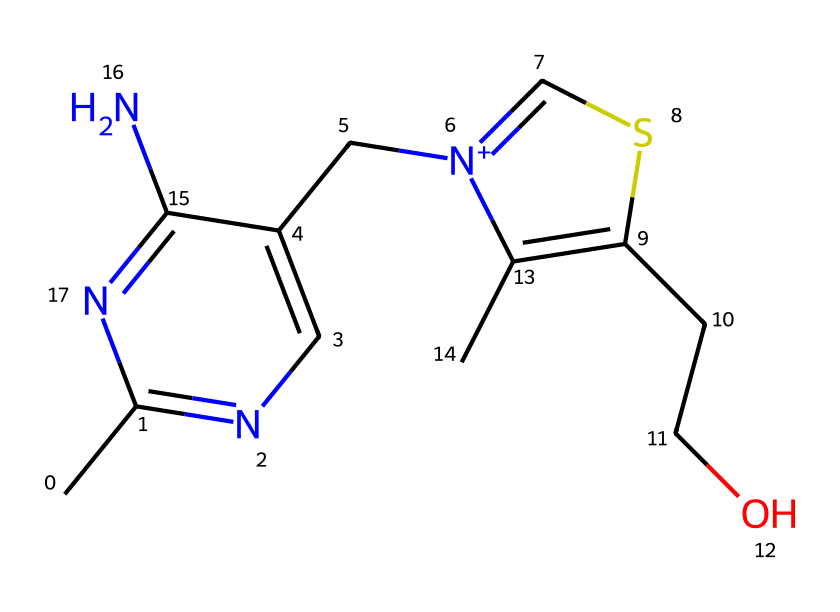What is the main functional group present in thiamine (Vitamin B1)? The main functional group in thiamine is the thiazole ring, which contains sulfur and nitrogen. This can be identified by looking for the five-membered ring that includes sulfur as part of its structure.
Answer: thiazole ring How many nitrogen atoms are in the thiamine structure? To determine the number of nitrogen atoms, I can simply count the 'N' symbols in the SMILES representation. There are two 'N' symbols present, indicating two nitrogen atoms in the structure.
Answer: two What type of molecule is thiamine categorized as? Thiamine is categorized as a vitamin, specifically B1. It is a water-soluble vitamin that plays a crucial role in carbohydrate metabolism. The chemical structure indicates that it is a small organic molecule.
Answer: vitamin How many carbon atoms are in thiamine? By analyzing the SMILES notation, I can count the occurrences of 'C' that represent carbon atoms. There are seven 'C' symbols, indicating that thiamine contains seven carbon atoms.
Answer: seven Is the thiamine structure aromatic? To evaluate if the structure is aromatic, I can check for cyclic structures that comply with Huckel's rule (4n + 2 π electrons) and also display delocalized electrons. The presence of the two rings suggests potential aromatic characteristics. Based on its structure, thiamine is not fully aromatic but has components that have resonance.
Answer: no What is the functional role of thiamine in metabolism? Thiamine plays a key role in converting carbohydrates into energy, specifically aiding in the decarboxylation of alpha-keto acids. Its structure allows it to work as a coenzyme in these metabolic pathways.
Answer: energy metabolism 